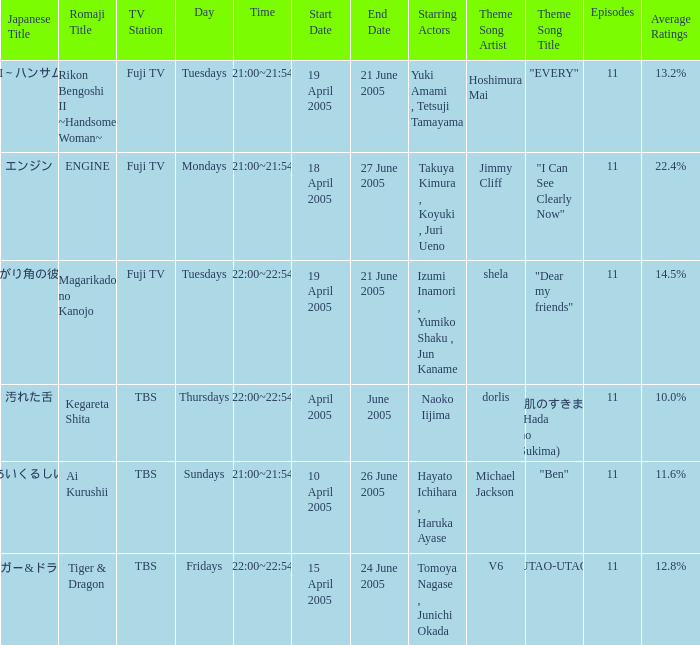What is the title with an average rating of 22.4%? ENGINE. 